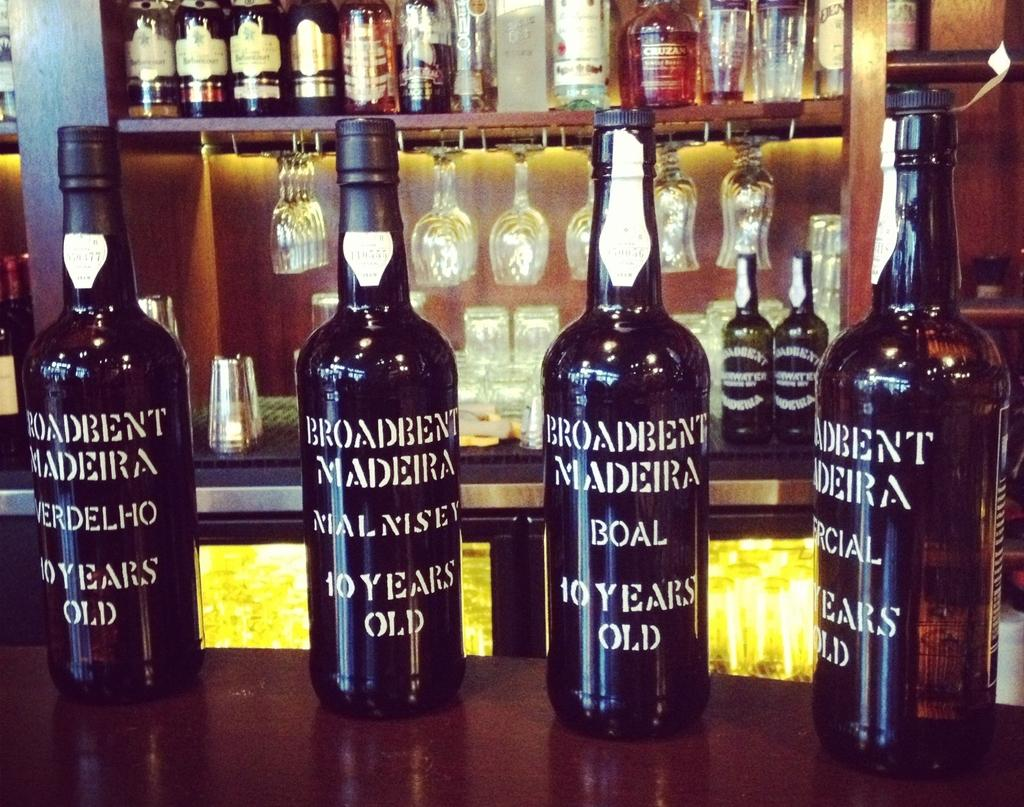Provide a one-sentence caption for the provided image. Four bottles of Madeira wine rest on the counter top. 